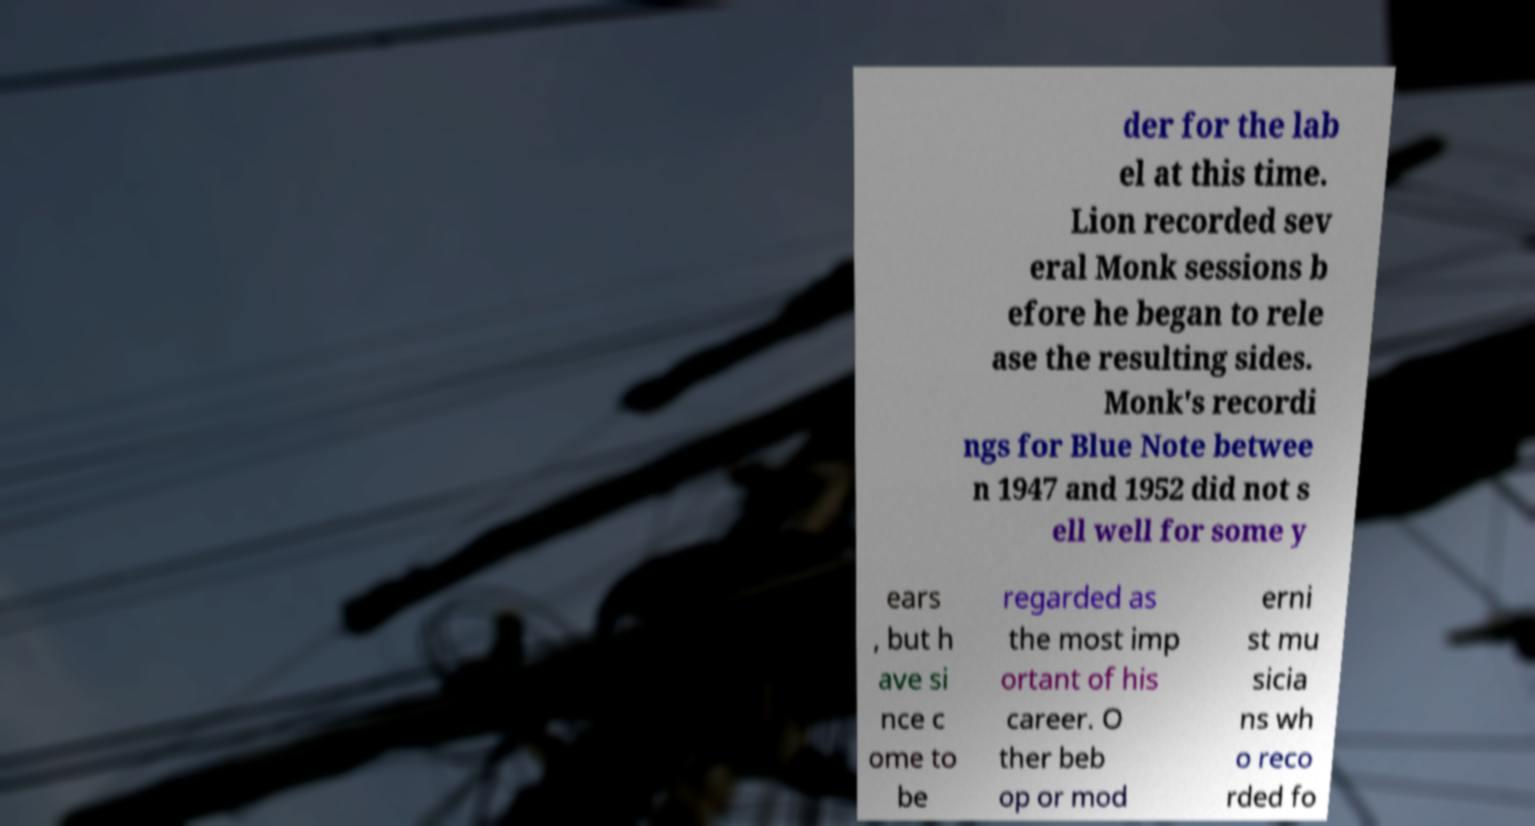Could you assist in decoding the text presented in this image and type it out clearly? der for the lab el at this time. Lion recorded sev eral Monk sessions b efore he began to rele ase the resulting sides. Monk's recordi ngs for Blue Note betwee n 1947 and 1952 did not s ell well for some y ears , but h ave si nce c ome to be regarded as the most imp ortant of his career. O ther beb op or mod erni st mu sicia ns wh o reco rded fo 